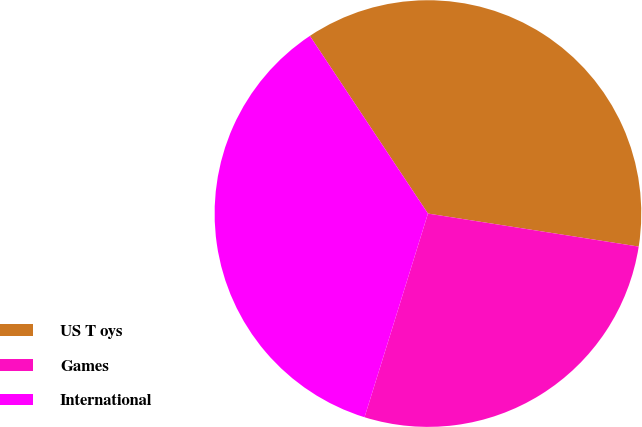Convert chart. <chart><loc_0><loc_0><loc_500><loc_500><pie_chart><fcel>US T oys<fcel>Games<fcel>International<nl><fcel>36.81%<fcel>27.33%<fcel>35.86%<nl></chart> 